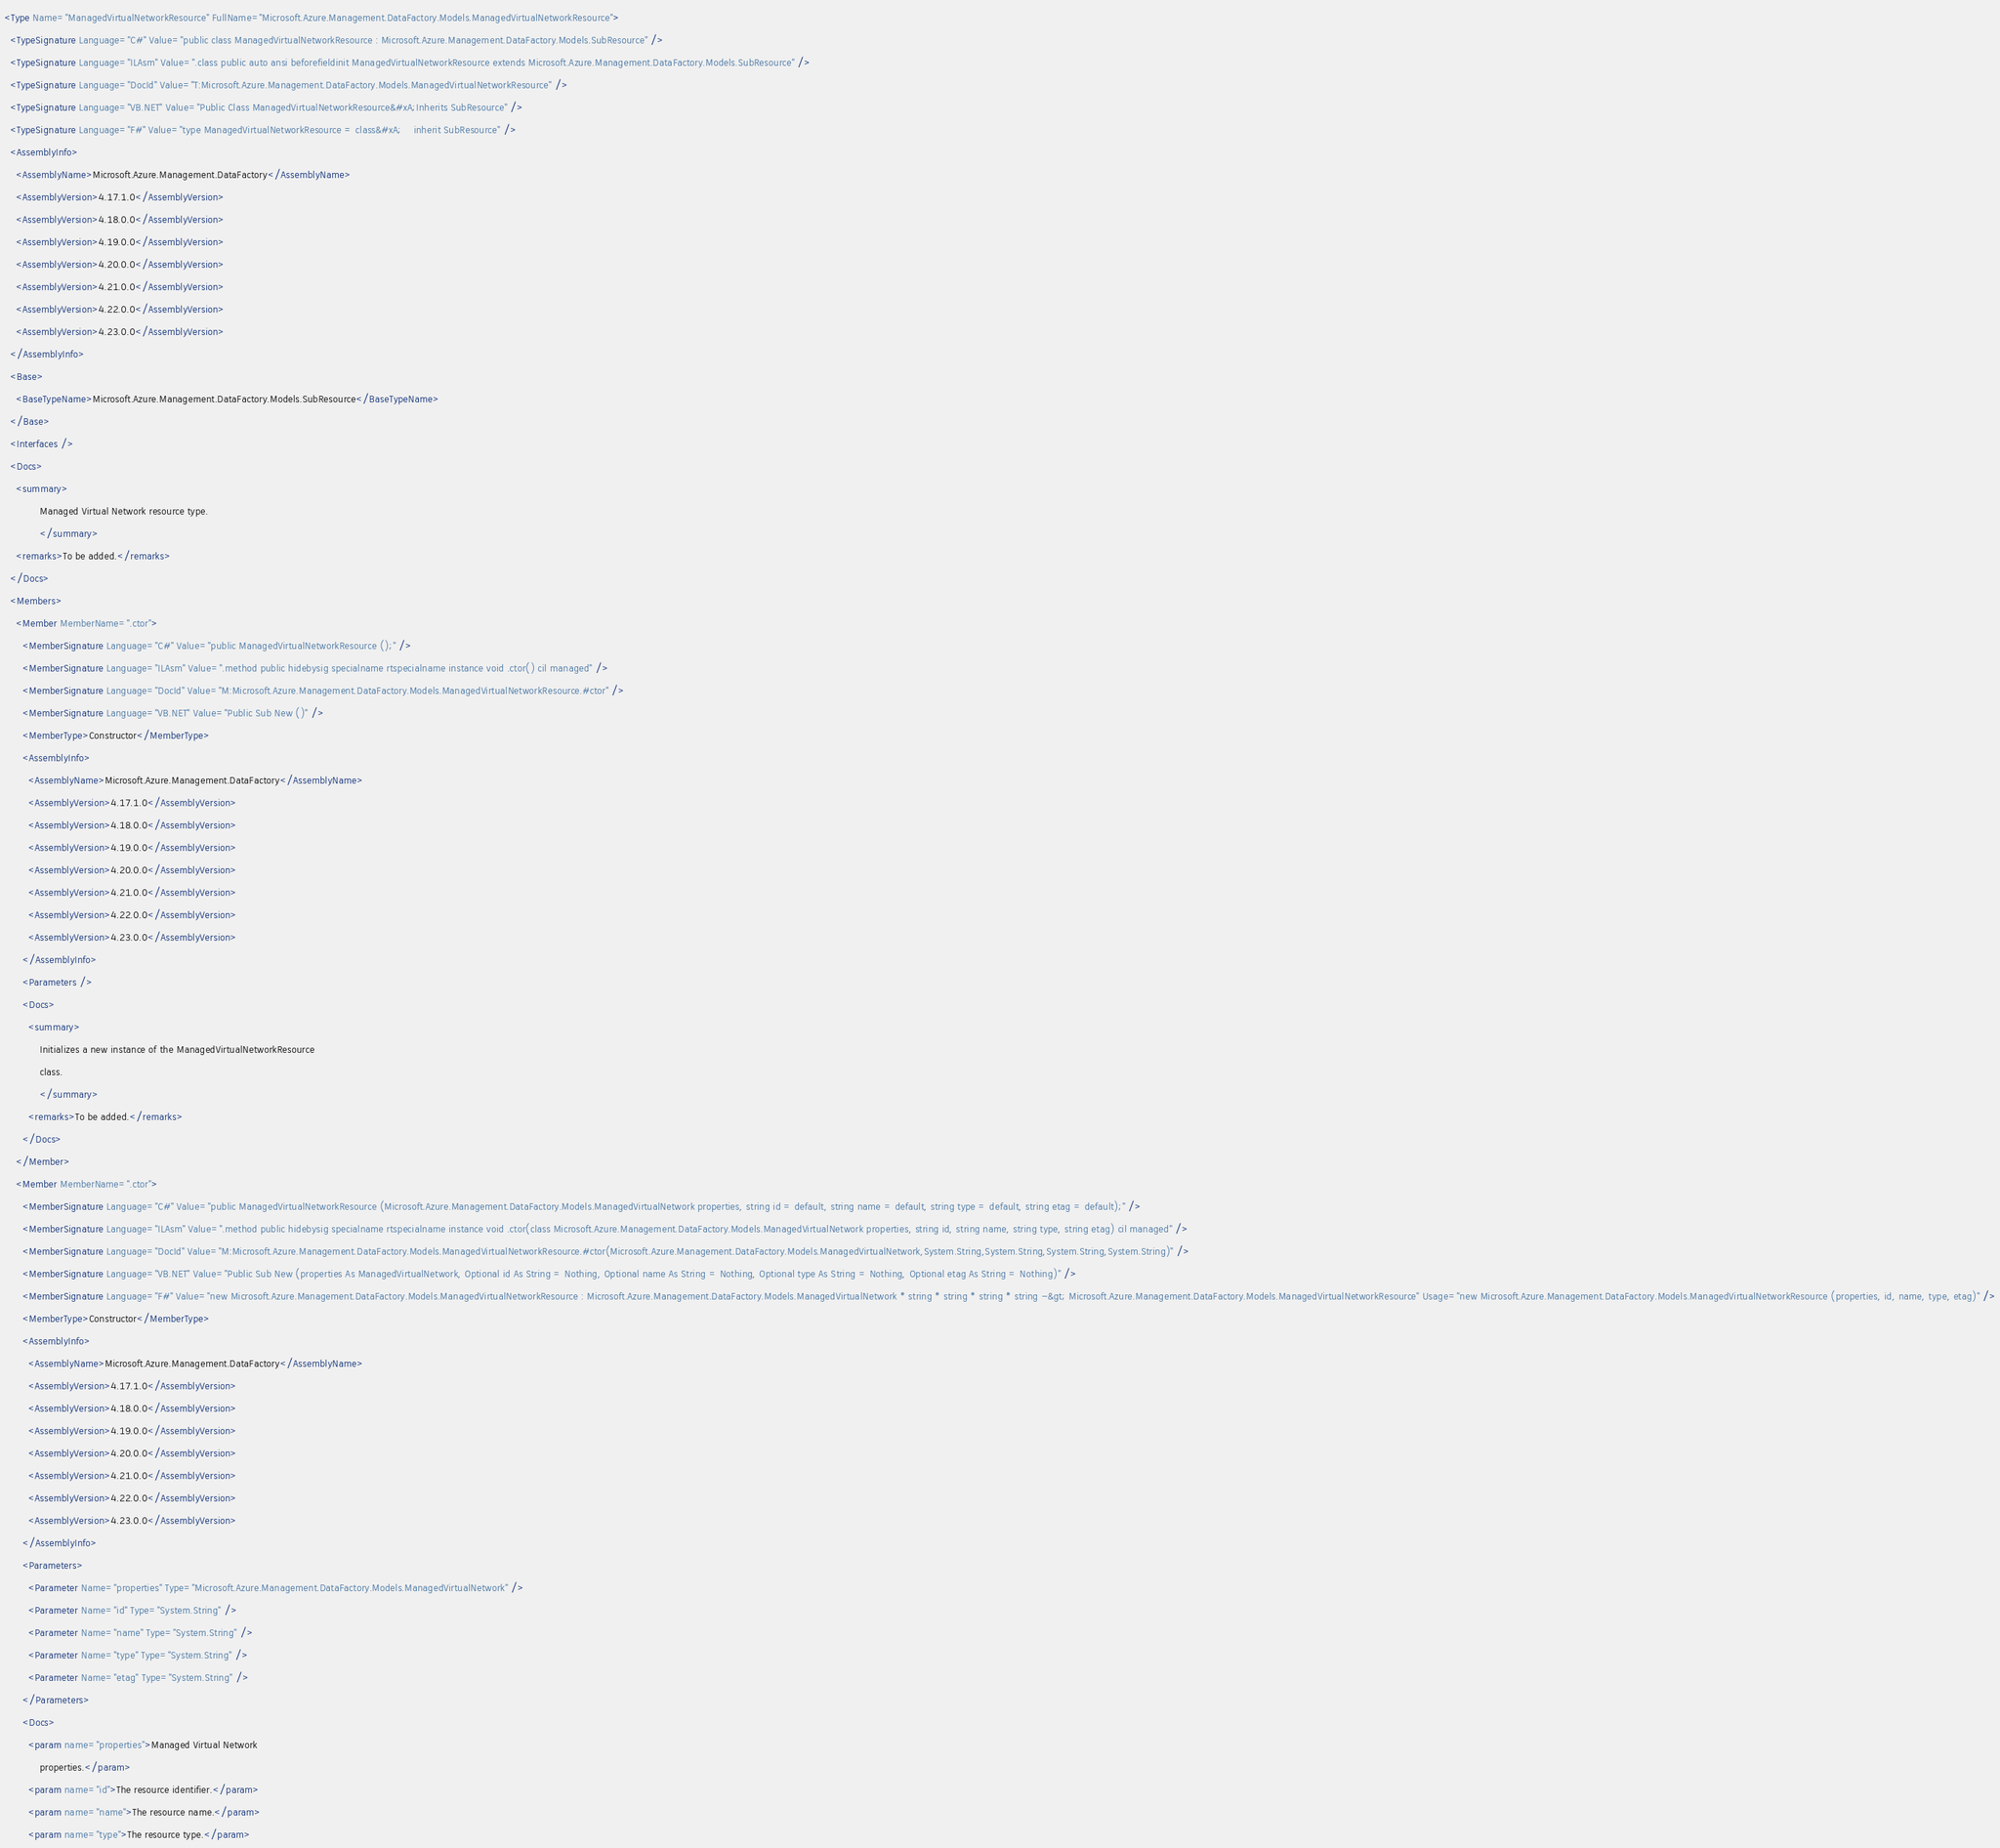Convert code to text. <code><loc_0><loc_0><loc_500><loc_500><_XML_><Type Name="ManagedVirtualNetworkResource" FullName="Microsoft.Azure.Management.DataFactory.Models.ManagedVirtualNetworkResource">
  <TypeSignature Language="C#" Value="public class ManagedVirtualNetworkResource : Microsoft.Azure.Management.DataFactory.Models.SubResource" />
  <TypeSignature Language="ILAsm" Value=".class public auto ansi beforefieldinit ManagedVirtualNetworkResource extends Microsoft.Azure.Management.DataFactory.Models.SubResource" />
  <TypeSignature Language="DocId" Value="T:Microsoft.Azure.Management.DataFactory.Models.ManagedVirtualNetworkResource" />
  <TypeSignature Language="VB.NET" Value="Public Class ManagedVirtualNetworkResource&#xA;Inherits SubResource" />
  <TypeSignature Language="F#" Value="type ManagedVirtualNetworkResource = class&#xA;    inherit SubResource" />
  <AssemblyInfo>
    <AssemblyName>Microsoft.Azure.Management.DataFactory</AssemblyName>
    <AssemblyVersion>4.17.1.0</AssemblyVersion>
    <AssemblyVersion>4.18.0.0</AssemblyVersion>
    <AssemblyVersion>4.19.0.0</AssemblyVersion>
    <AssemblyVersion>4.20.0.0</AssemblyVersion>
    <AssemblyVersion>4.21.0.0</AssemblyVersion>
    <AssemblyVersion>4.22.0.0</AssemblyVersion>
    <AssemblyVersion>4.23.0.0</AssemblyVersion>
  </AssemblyInfo>
  <Base>
    <BaseTypeName>Microsoft.Azure.Management.DataFactory.Models.SubResource</BaseTypeName>
  </Base>
  <Interfaces />
  <Docs>
    <summary>
            Managed Virtual Network resource type.
            </summary>
    <remarks>To be added.</remarks>
  </Docs>
  <Members>
    <Member MemberName=".ctor">
      <MemberSignature Language="C#" Value="public ManagedVirtualNetworkResource ();" />
      <MemberSignature Language="ILAsm" Value=".method public hidebysig specialname rtspecialname instance void .ctor() cil managed" />
      <MemberSignature Language="DocId" Value="M:Microsoft.Azure.Management.DataFactory.Models.ManagedVirtualNetworkResource.#ctor" />
      <MemberSignature Language="VB.NET" Value="Public Sub New ()" />
      <MemberType>Constructor</MemberType>
      <AssemblyInfo>
        <AssemblyName>Microsoft.Azure.Management.DataFactory</AssemblyName>
        <AssemblyVersion>4.17.1.0</AssemblyVersion>
        <AssemblyVersion>4.18.0.0</AssemblyVersion>
        <AssemblyVersion>4.19.0.0</AssemblyVersion>
        <AssemblyVersion>4.20.0.0</AssemblyVersion>
        <AssemblyVersion>4.21.0.0</AssemblyVersion>
        <AssemblyVersion>4.22.0.0</AssemblyVersion>
        <AssemblyVersion>4.23.0.0</AssemblyVersion>
      </AssemblyInfo>
      <Parameters />
      <Docs>
        <summary>
            Initializes a new instance of the ManagedVirtualNetworkResource
            class.
            </summary>
        <remarks>To be added.</remarks>
      </Docs>
    </Member>
    <Member MemberName=".ctor">
      <MemberSignature Language="C#" Value="public ManagedVirtualNetworkResource (Microsoft.Azure.Management.DataFactory.Models.ManagedVirtualNetwork properties, string id = default, string name = default, string type = default, string etag = default);" />
      <MemberSignature Language="ILAsm" Value=".method public hidebysig specialname rtspecialname instance void .ctor(class Microsoft.Azure.Management.DataFactory.Models.ManagedVirtualNetwork properties, string id, string name, string type, string etag) cil managed" />
      <MemberSignature Language="DocId" Value="M:Microsoft.Azure.Management.DataFactory.Models.ManagedVirtualNetworkResource.#ctor(Microsoft.Azure.Management.DataFactory.Models.ManagedVirtualNetwork,System.String,System.String,System.String,System.String)" />
      <MemberSignature Language="VB.NET" Value="Public Sub New (properties As ManagedVirtualNetwork, Optional id As String = Nothing, Optional name As String = Nothing, Optional type As String = Nothing, Optional etag As String = Nothing)" />
      <MemberSignature Language="F#" Value="new Microsoft.Azure.Management.DataFactory.Models.ManagedVirtualNetworkResource : Microsoft.Azure.Management.DataFactory.Models.ManagedVirtualNetwork * string * string * string * string -&gt; Microsoft.Azure.Management.DataFactory.Models.ManagedVirtualNetworkResource" Usage="new Microsoft.Azure.Management.DataFactory.Models.ManagedVirtualNetworkResource (properties, id, name, type, etag)" />
      <MemberType>Constructor</MemberType>
      <AssemblyInfo>
        <AssemblyName>Microsoft.Azure.Management.DataFactory</AssemblyName>
        <AssemblyVersion>4.17.1.0</AssemblyVersion>
        <AssemblyVersion>4.18.0.0</AssemblyVersion>
        <AssemblyVersion>4.19.0.0</AssemblyVersion>
        <AssemblyVersion>4.20.0.0</AssemblyVersion>
        <AssemblyVersion>4.21.0.0</AssemblyVersion>
        <AssemblyVersion>4.22.0.0</AssemblyVersion>
        <AssemblyVersion>4.23.0.0</AssemblyVersion>
      </AssemblyInfo>
      <Parameters>
        <Parameter Name="properties" Type="Microsoft.Azure.Management.DataFactory.Models.ManagedVirtualNetwork" />
        <Parameter Name="id" Type="System.String" />
        <Parameter Name="name" Type="System.String" />
        <Parameter Name="type" Type="System.String" />
        <Parameter Name="etag" Type="System.String" />
      </Parameters>
      <Docs>
        <param name="properties">Managed Virtual Network
            properties.</param>
        <param name="id">The resource identifier.</param>
        <param name="name">The resource name.</param>
        <param name="type">The resource type.</param></code> 